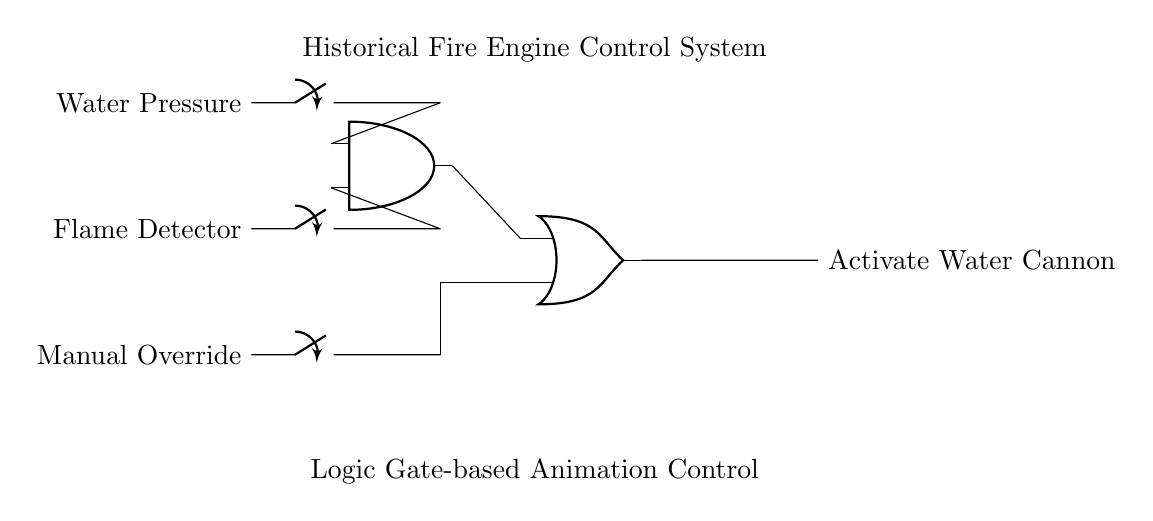What is the purpose of the AND gate in the circuit? The AND gate combines two inputs: water pressure and flame detection. It activates its output only when both conditions are true, indicating both the presence of water pressure and a flame.
Answer: Activating water cannon What inputs are connected to the OR gate? The OR gate receives output from the AND gate and input from the manual override switch. This means that either the condition from the AND gate or the manual override can activate the output.
Answer: AND output and manual override How many switches are present in this circuit? The circuit includes three switches that control water pressure, flame detection, and manual override. Each switch represents a different input condition for the control system.
Answer: Three What activates the water cannon in the system? The water cannon is activated if both water pressure is present and a flame is detected, or if the manual override is engaged. The OR gate finalizes the output based on these conditions being met.
Answer: Water pressure and flame detection or manual override What does the flame detector represent in this circuit? The flame detector acts as an input switch that indicates whether a flame is present or not. If it detects a flame, it provides one of the necessary inputs to the AND gate to activate the system.
Answer: Input switch 